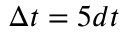<formula> <loc_0><loc_0><loc_500><loc_500>\Delta t = 5 d t</formula> 